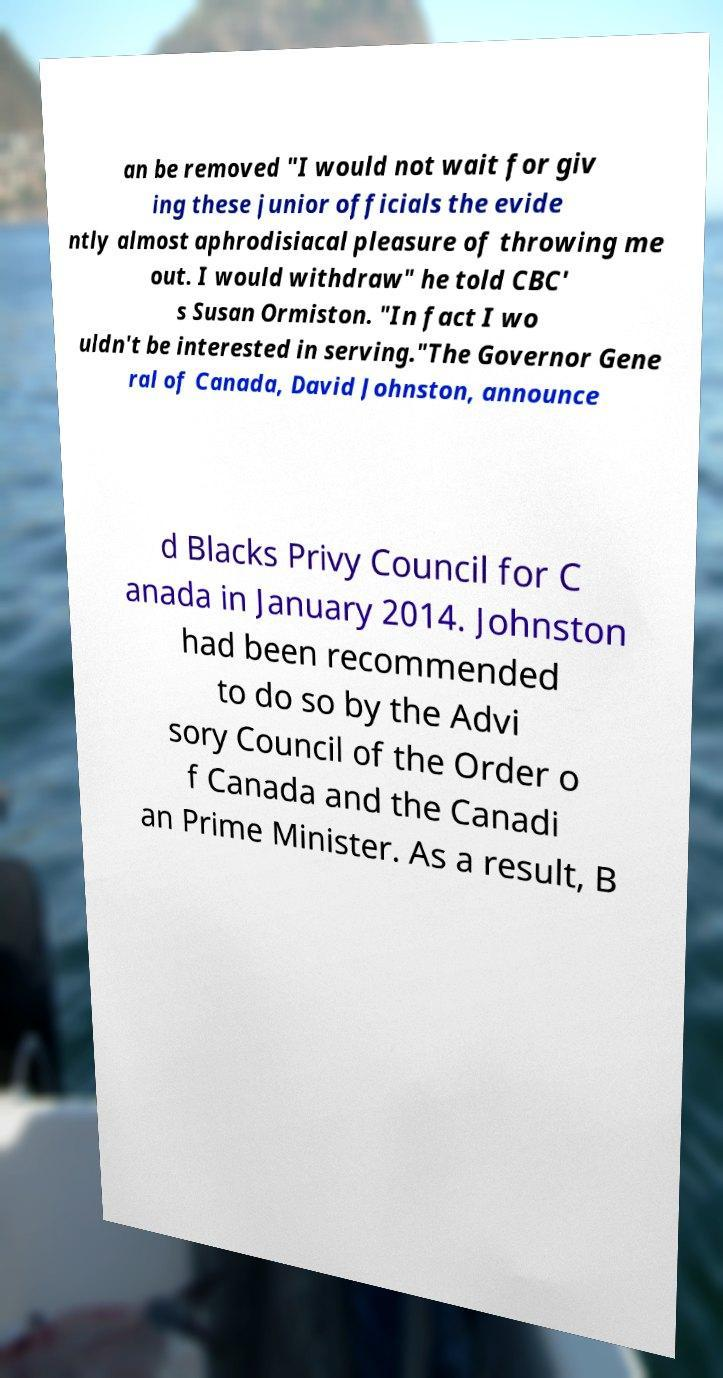What messages or text are displayed in this image? I need them in a readable, typed format. an be removed "I would not wait for giv ing these junior officials the evide ntly almost aphrodisiacal pleasure of throwing me out. I would withdraw" he told CBC' s Susan Ormiston. "In fact I wo uldn't be interested in serving."The Governor Gene ral of Canada, David Johnston, announce d Blacks Privy Council for C anada in January 2014. Johnston had been recommended to do so by the Advi sory Council of the Order o f Canada and the Canadi an Prime Minister. As a result, B 